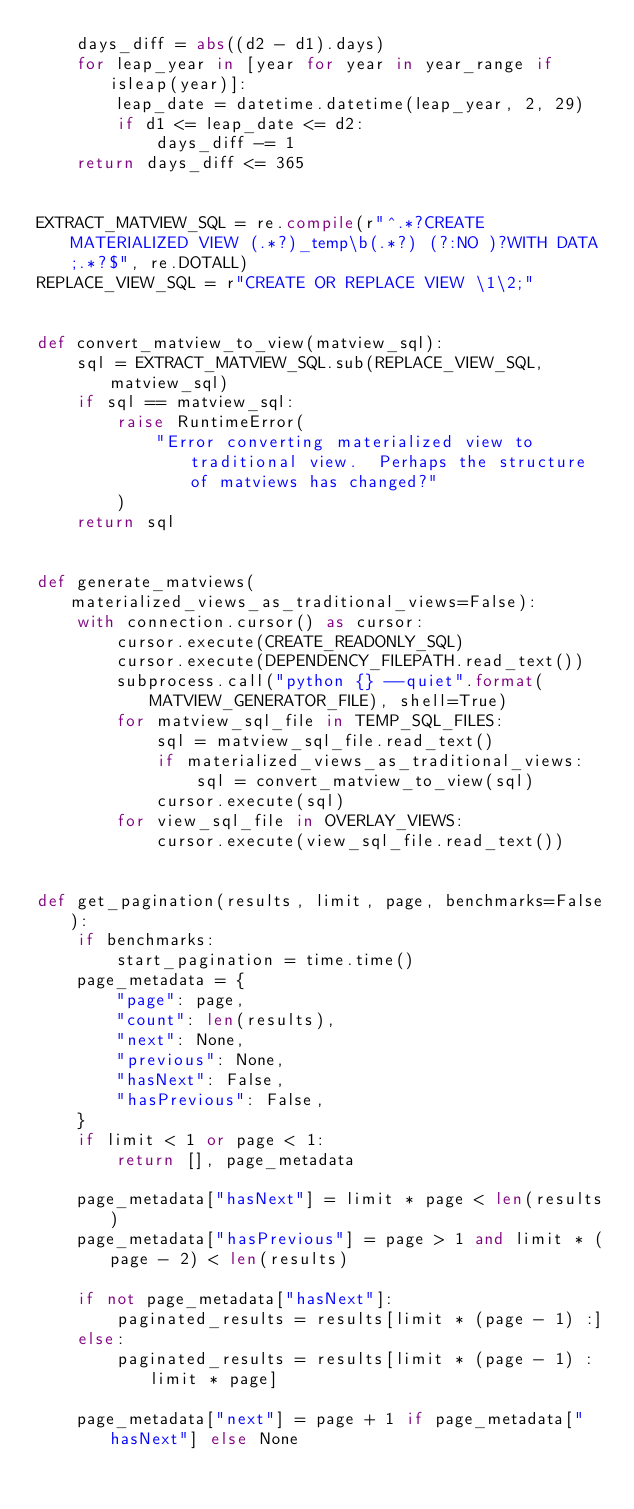<code> <loc_0><loc_0><loc_500><loc_500><_Python_>    days_diff = abs((d2 - d1).days)
    for leap_year in [year for year in year_range if isleap(year)]:
        leap_date = datetime.datetime(leap_year, 2, 29)
        if d1 <= leap_date <= d2:
            days_diff -= 1
    return days_diff <= 365


EXTRACT_MATVIEW_SQL = re.compile(r"^.*?CREATE MATERIALIZED VIEW (.*?)_temp\b(.*?) (?:NO )?WITH DATA;.*?$", re.DOTALL)
REPLACE_VIEW_SQL = r"CREATE OR REPLACE VIEW \1\2;"


def convert_matview_to_view(matview_sql):
    sql = EXTRACT_MATVIEW_SQL.sub(REPLACE_VIEW_SQL, matview_sql)
    if sql == matview_sql:
        raise RuntimeError(
            "Error converting materialized view to traditional view.  Perhaps the structure of matviews has changed?"
        )
    return sql


def generate_matviews(materialized_views_as_traditional_views=False):
    with connection.cursor() as cursor:
        cursor.execute(CREATE_READONLY_SQL)
        cursor.execute(DEPENDENCY_FILEPATH.read_text())
        subprocess.call("python {} --quiet".format(MATVIEW_GENERATOR_FILE), shell=True)
        for matview_sql_file in TEMP_SQL_FILES:
            sql = matview_sql_file.read_text()
            if materialized_views_as_traditional_views:
                sql = convert_matview_to_view(sql)
            cursor.execute(sql)
        for view_sql_file in OVERLAY_VIEWS:
            cursor.execute(view_sql_file.read_text())


def get_pagination(results, limit, page, benchmarks=False):
    if benchmarks:
        start_pagination = time.time()
    page_metadata = {
        "page": page,
        "count": len(results),
        "next": None,
        "previous": None,
        "hasNext": False,
        "hasPrevious": False,
    }
    if limit < 1 or page < 1:
        return [], page_metadata

    page_metadata["hasNext"] = limit * page < len(results)
    page_metadata["hasPrevious"] = page > 1 and limit * (page - 2) < len(results)

    if not page_metadata["hasNext"]:
        paginated_results = results[limit * (page - 1) :]
    else:
        paginated_results = results[limit * (page - 1) : limit * page]

    page_metadata["next"] = page + 1 if page_metadata["hasNext"] else None</code> 